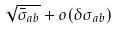<formula> <loc_0><loc_0><loc_500><loc_500>\sqrt { \bar { \sigma } _ { a b } } + o ( \delta \sigma _ { a b } )</formula> 